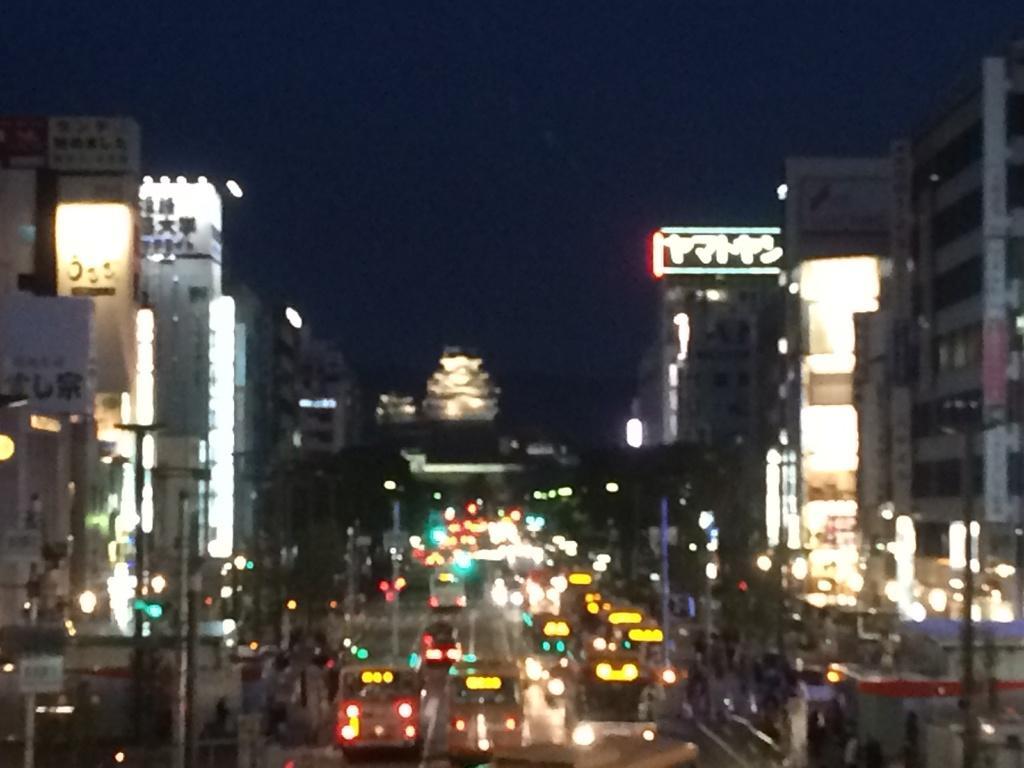How would you summarize this image in a sentence or two? In this image, I can see buildings, vehicles on the road and lights. In the background, there is the sky. 